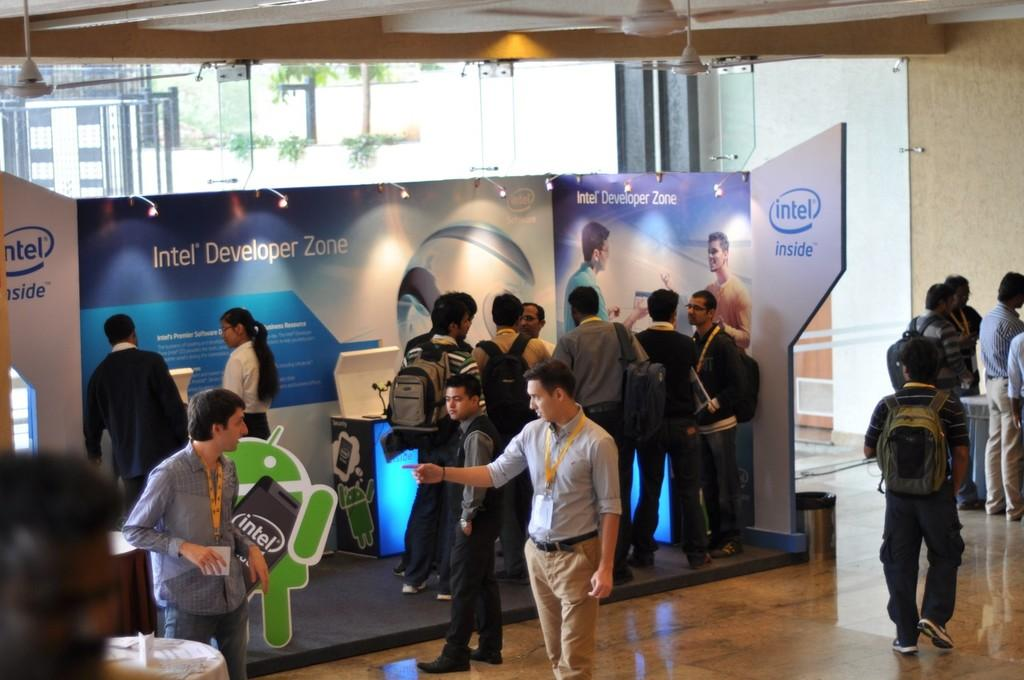What is happening in the image? There is a group of people in the image, and they are standing. What are the people wearing? The people are wearing bags. What can be seen in the background of the image? There is a banner with blue and white colors, a glass door, and trees with green color in the background of the image. What type of pleasure can be seen on the table in the image? There is no table present in the image, so it is not possible to determine if any pleasure is visible on a table. 